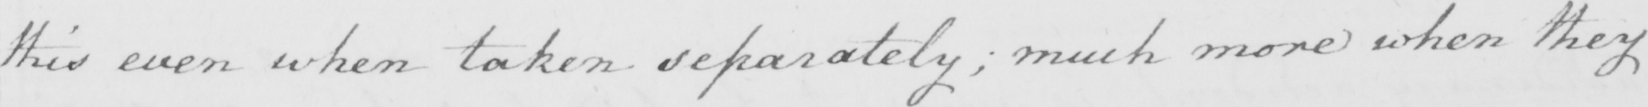Please transcribe the handwritten text in this image. this even when taken separately; much more when they 